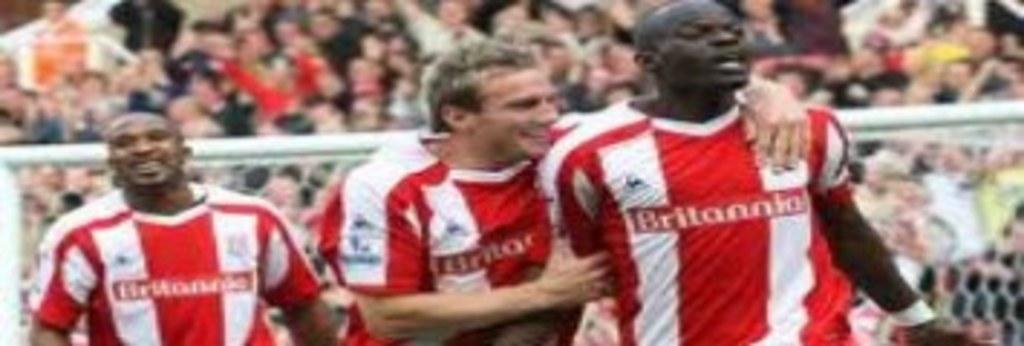How many people are in the image? There are three men in the image. What can be seen in the background of the image? There is a net and people in the background of the image. What type of business are the men discussing in the image? There is no indication in the image that the men are discussing any business. 